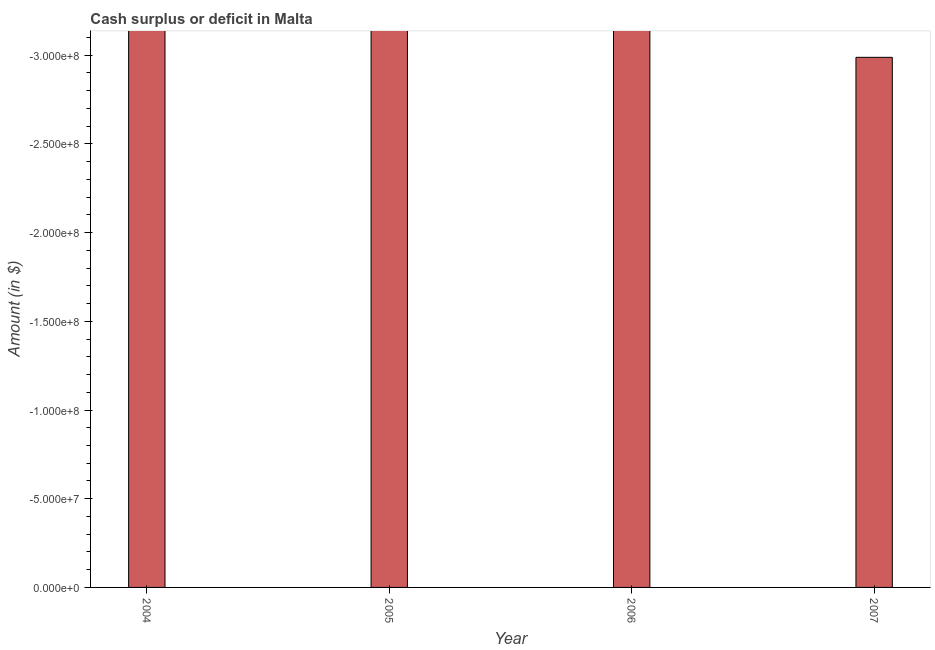Does the graph contain any zero values?
Your answer should be compact. Yes. Does the graph contain grids?
Provide a short and direct response. No. What is the title of the graph?
Offer a very short reply. Cash surplus or deficit in Malta. What is the label or title of the X-axis?
Offer a terse response. Year. What is the label or title of the Y-axis?
Ensure brevity in your answer.  Amount (in $). What is the cash surplus or deficit in 2006?
Your answer should be very brief. 0. Across all years, what is the minimum cash surplus or deficit?
Your response must be concise. 0. What is the median cash surplus or deficit?
Your answer should be very brief. 0. In how many years, is the cash surplus or deficit greater than -80000000 $?
Give a very brief answer. 0. How many bars are there?
Offer a terse response. 0. How many years are there in the graph?
Provide a succinct answer. 4. What is the Amount (in $) of 2004?
Provide a succinct answer. 0. What is the Amount (in $) in 2006?
Give a very brief answer. 0. What is the Amount (in $) of 2007?
Provide a succinct answer. 0. 